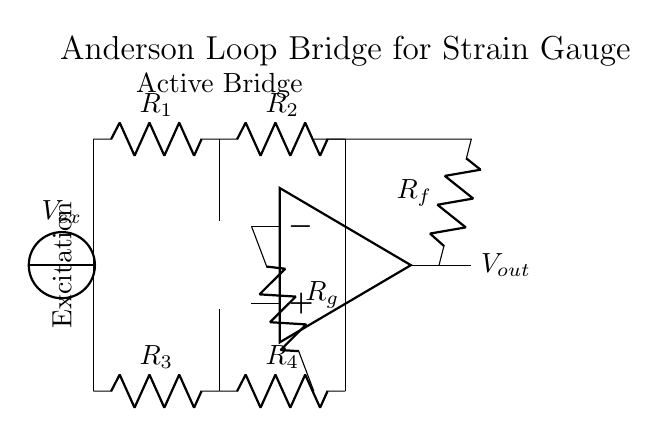What is the output voltage in this circuit? The output voltage is represented as V_out, which is the result after the amplification of the difference voltage seen by the op-amp. This is directly linked to the strain gauges.
Answer: V_out What is the excitation voltage in this circuit? The excitation voltage is labeled as V_ex, indicating the voltage supplied to the strain gauges for their operation. It is the starting point for the voltage measurement circuit.
Answer: V_ex How many strain gauges are used in the bridge? There are four resistors labeled R1, R2, R3, and R4 in the diagram, which correspond to the four strain gauges configured in a Wheatstone bridge formation.
Answer: Four What type of bridge is illustrated in this circuit? The circuit is an Anderson loop bridge, specifically designed for applications involving strain gauges, which are used in measuring force or pressure.
Answer: Anderson loop bridge What do the resistors R_f and R_g represent? R_f is a feedback resistor that forms part of the op-amp's feedback loop, controlling gain. R_g is a gain resistor that helps set the sensitivity of the output to changes in resistance from the strain gauges.
Answer: Feedback and gain resistors What is the role of the operational amplifier in this circuit? The operational amplifier is used to amplify the differential voltage created by the resistance changes in the strain gauges, providing a measurable output voltage that corresponds to the strain measurement.
Answer: Amplification of differential voltage 